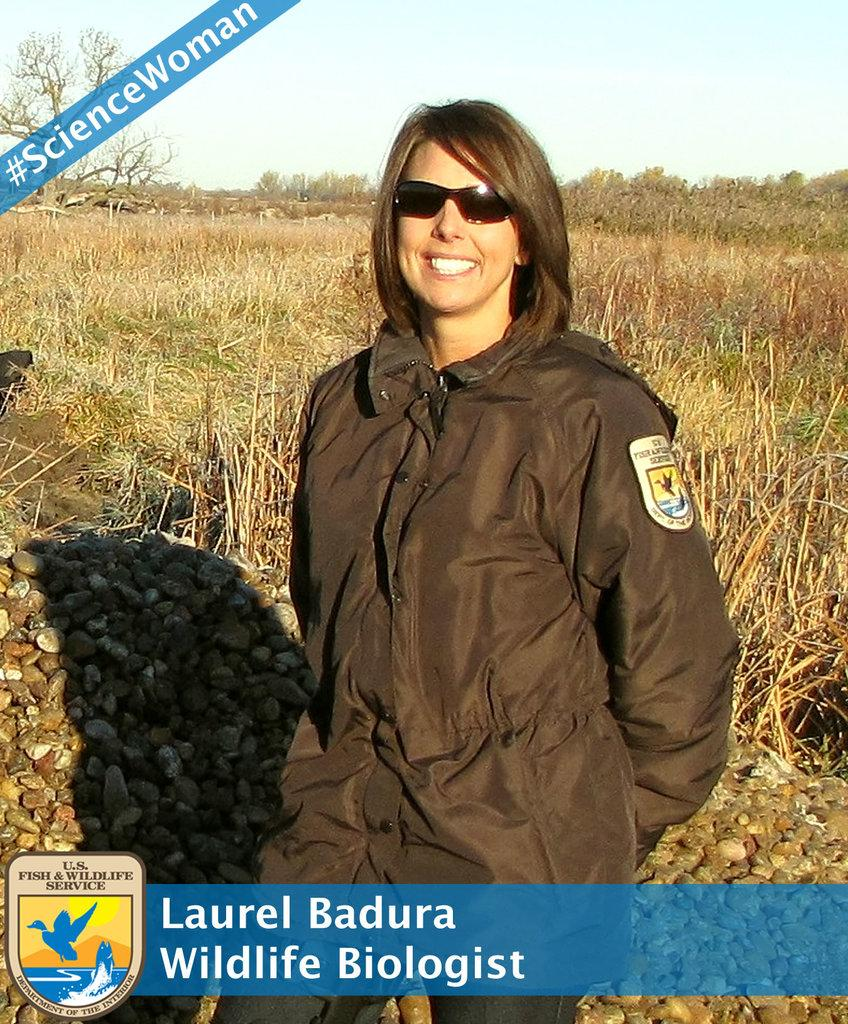Who is the person in the image? There is a woman in the image. What is the woman standing in front of? The woman is standing in front of plants. What can be seen behind the woman? There are many stones behind the woman. Is there any information about the woman's identity provided in the image? Yes, the name of the woman is mentioned below the picture. What type of record does the woman hold in her hand in the image? There is no record visible in the woman's hand in the image. 